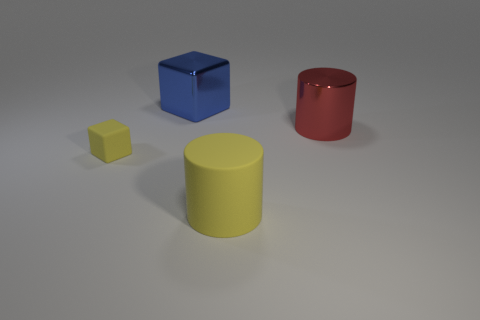Is the tiny cube the same color as the large matte cylinder?
Provide a short and direct response. Yes. What size is the thing that is the same color as the tiny cube?
Ensure brevity in your answer.  Large. Is there a metal block of the same color as the matte cylinder?
Give a very brief answer. No. What is the color of the other cylinder that is the same size as the yellow cylinder?
Offer a terse response. Red. There is a yellow object that is to the right of the yellow object that is to the left of the object in front of the tiny object; what is its material?
Your response must be concise. Rubber. Do the tiny thing and the cylinder behind the small yellow cube have the same color?
Ensure brevity in your answer.  No. What number of things are big shiny things on the left side of the big yellow rubber cylinder or large things in front of the large metallic block?
Provide a short and direct response. 3. What shape is the rubber thing that is behind the large cylinder in front of the tiny yellow block?
Make the answer very short. Cube. Is there a large ball that has the same material as the big yellow cylinder?
Keep it short and to the point. No. The big rubber object that is the same shape as the large red metal thing is what color?
Your answer should be very brief. Yellow. 